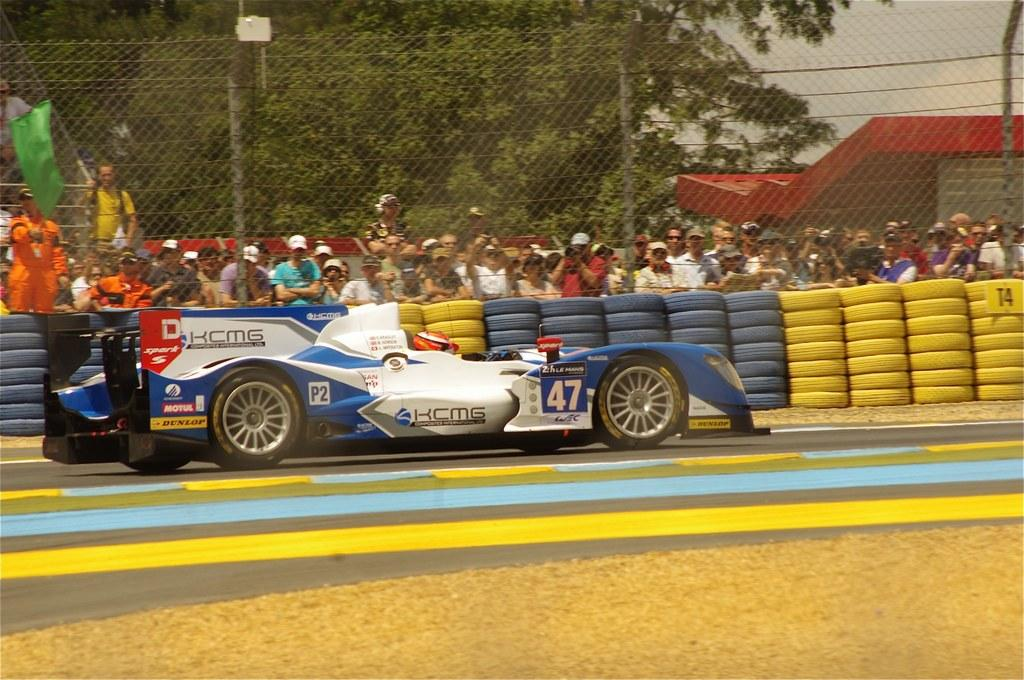What type of vehicle is on the road in the image? There is a sports car on the road in the image. What part of the sports car is visible in the image? Tires are visible in the image. What is located near the road in the image? There is a fence in the image. Can you describe the people in the image? There is a crowd visible in the image. What structure is on the right side of the image? There is a shed on the right side of the image. What type of natural environment is visible in the image? Trees are visible in the image. What is visible above the scene in the image? The sky is visible in the image. What type of loaf is being transported by the train in the image? There is no train or loaf present in the image; it features a sports car on the road. What type of railway is visible in the image? There is no railway present in the image. 